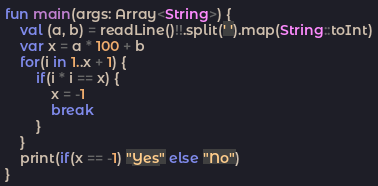<code> <loc_0><loc_0><loc_500><loc_500><_Kotlin_>fun main(args: Array<String>) {
    val (a, b) = readLine()!!.split(' ').map(String::toInt)
    var x = a * 100 + b
    for(i in 1..x + 1) {
        if(i * i == x) {
            x = -1
            break
        }
    }
    print(if(x == -1) "Yes" else "No")
}</code> 